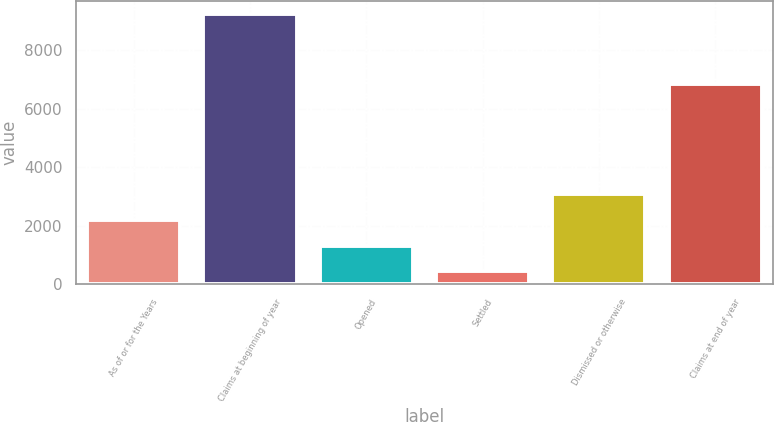Convert chart. <chart><loc_0><loc_0><loc_500><loc_500><bar_chart><fcel>As of or for the Years<fcel>Claims at beginning of year<fcel>Opened<fcel>Settled<fcel>Dismissed or otherwise<fcel>Claims at end of year<nl><fcel>2191.4<fcel>9225<fcel>1312.2<fcel>433<fcel>3070.6<fcel>6844<nl></chart> 